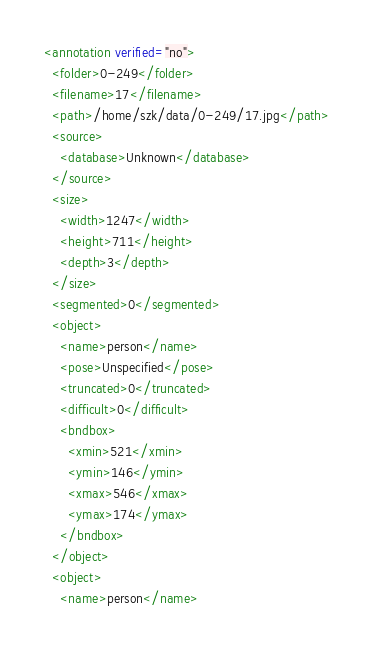Convert code to text. <code><loc_0><loc_0><loc_500><loc_500><_XML_><annotation verified="no">
  <folder>0-249</folder>
  <filename>17</filename>
  <path>/home/szk/data/0-249/17.jpg</path>
  <source>
    <database>Unknown</database>
  </source>
  <size>
    <width>1247</width>
    <height>711</height>
    <depth>3</depth>
  </size>
  <segmented>0</segmented>
  <object>
    <name>person</name>
    <pose>Unspecified</pose>
    <truncated>0</truncated>
    <difficult>0</difficult>
    <bndbox>
      <xmin>521</xmin>
      <ymin>146</ymin>
      <xmax>546</xmax>
      <ymax>174</ymax>
    </bndbox>
  </object>
  <object>
    <name>person</name></code> 